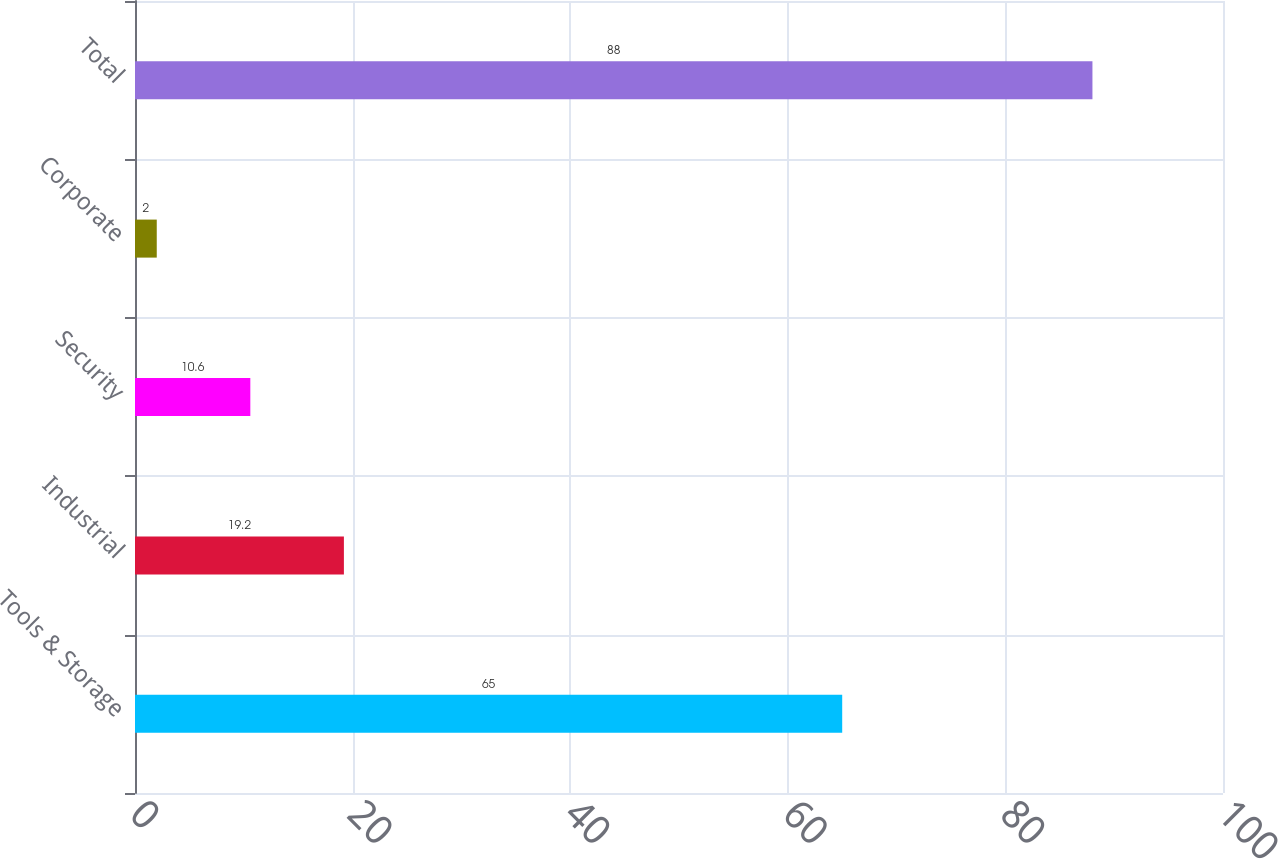Convert chart to OTSL. <chart><loc_0><loc_0><loc_500><loc_500><bar_chart><fcel>Tools & Storage<fcel>Industrial<fcel>Security<fcel>Corporate<fcel>Total<nl><fcel>65<fcel>19.2<fcel>10.6<fcel>2<fcel>88<nl></chart> 